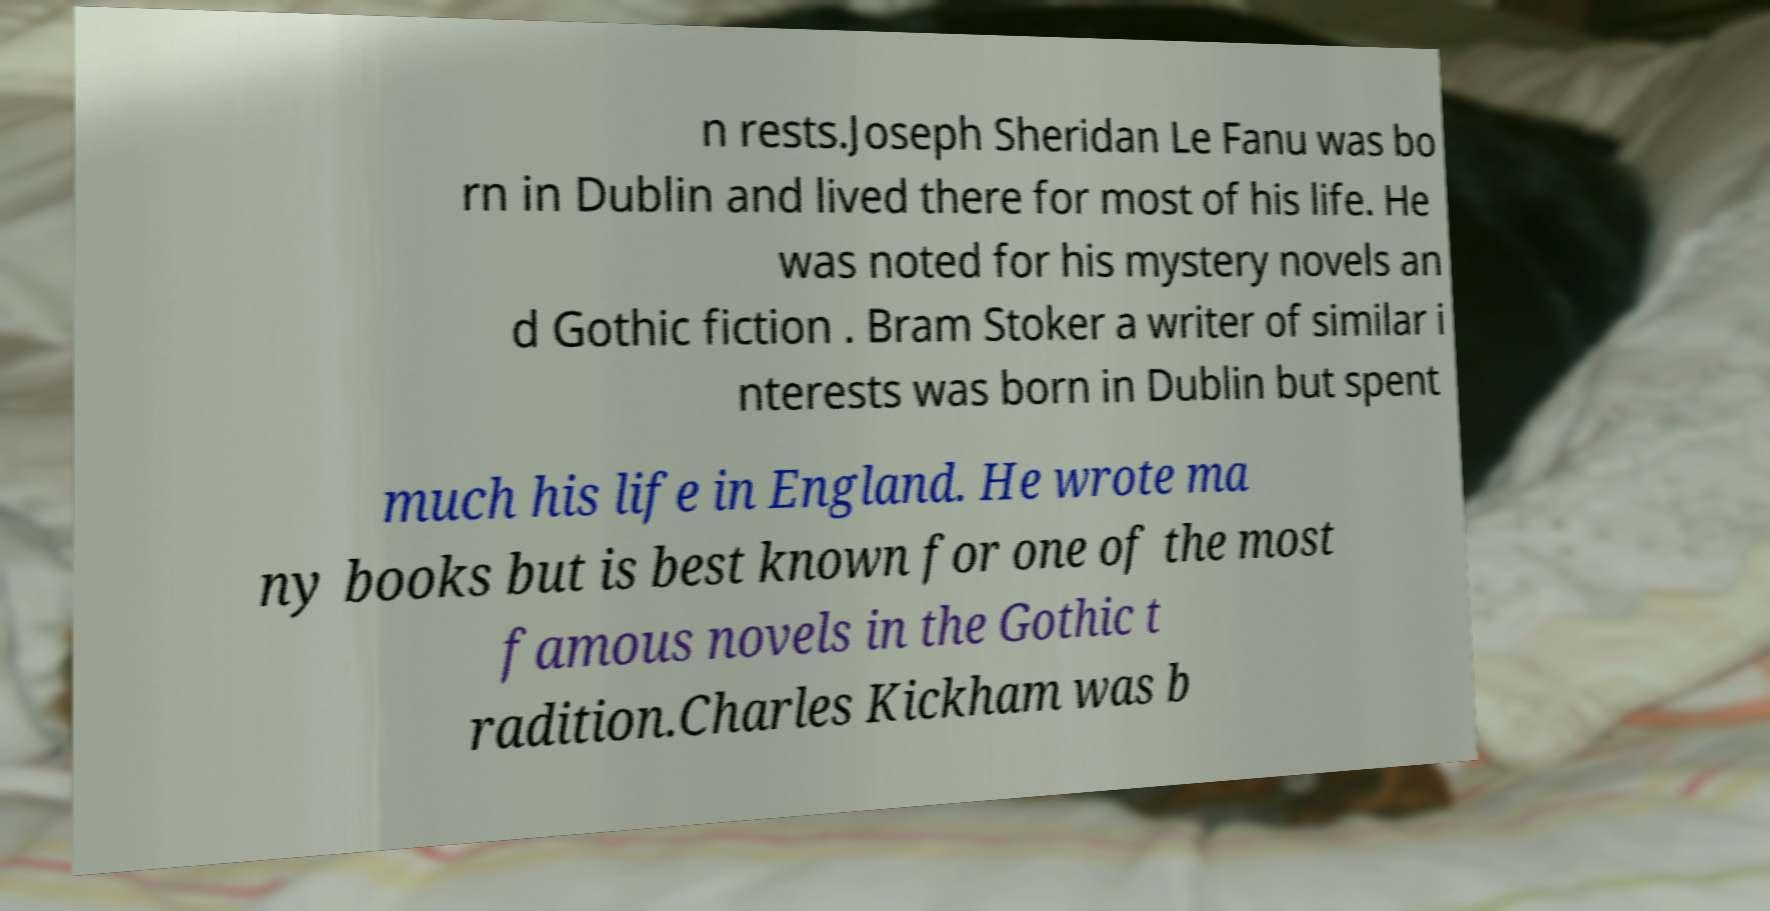Can you accurately transcribe the text from the provided image for me? n rests.Joseph Sheridan Le Fanu was bo rn in Dublin and lived there for most of his life. He was noted for his mystery novels an d Gothic fiction . Bram Stoker a writer of similar i nterests was born in Dublin but spent much his life in England. He wrote ma ny books but is best known for one of the most famous novels in the Gothic t radition.Charles Kickham was b 